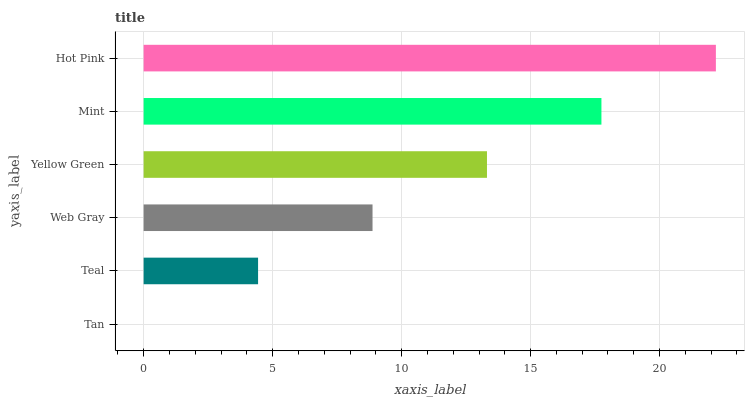Is Tan the minimum?
Answer yes or no. Yes. Is Hot Pink the maximum?
Answer yes or no. Yes. Is Teal the minimum?
Answer yes or no. No. Is Teal the maximum?
Answer yes or no. No. Is Teal greater than Tan?
Answer yes or no. Yes. Is Tan less than Teal?
Answer yes or no. Yes. Is Tan greater than Teal?
Answer yes or no. No. Is Teal less than Tan?
Answer yes or no. No. Is Yellow Green the high median?
Answer yes or no. Yes. Is Web Gray the low median?
Answer yes or no. Yes. Is Teal the high median?
Answer yes or no. No. Is Hot Pink the low median?
Answer yes or no. No. 